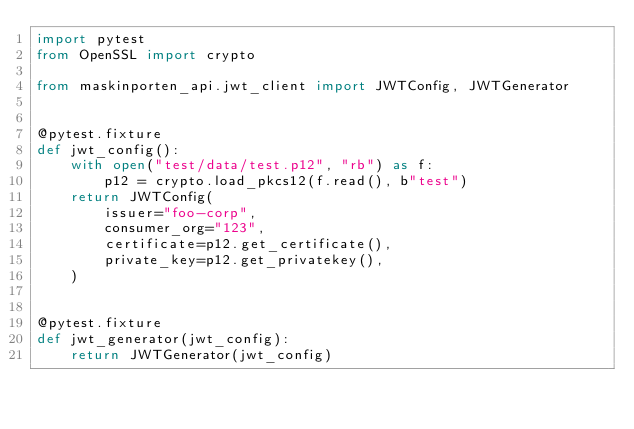<code> <loc_0><loc_0><loc_500><loc_500><_Python_>import pytest
from OpenSSL import crypto

from maskinporten_api.jwt_client import JWTConfig, JWTGenerator


@pytest.fixture
def jwt_config():
    with open("test/data/test.p12", "rb") as f:
        p12 = crypto.load_pkcs12(f.read(), b"test")
    return JWTConfig(
        issuer="foo-corp",
        consumer_org="123",
        certificate=p12.get_certificate(),
        private_key=p12.get_privatekey(),
    )


@pytest.fixture
def jwt_generator(jwt_config):
    return JWTGenerator(jwt_config)
</code> 